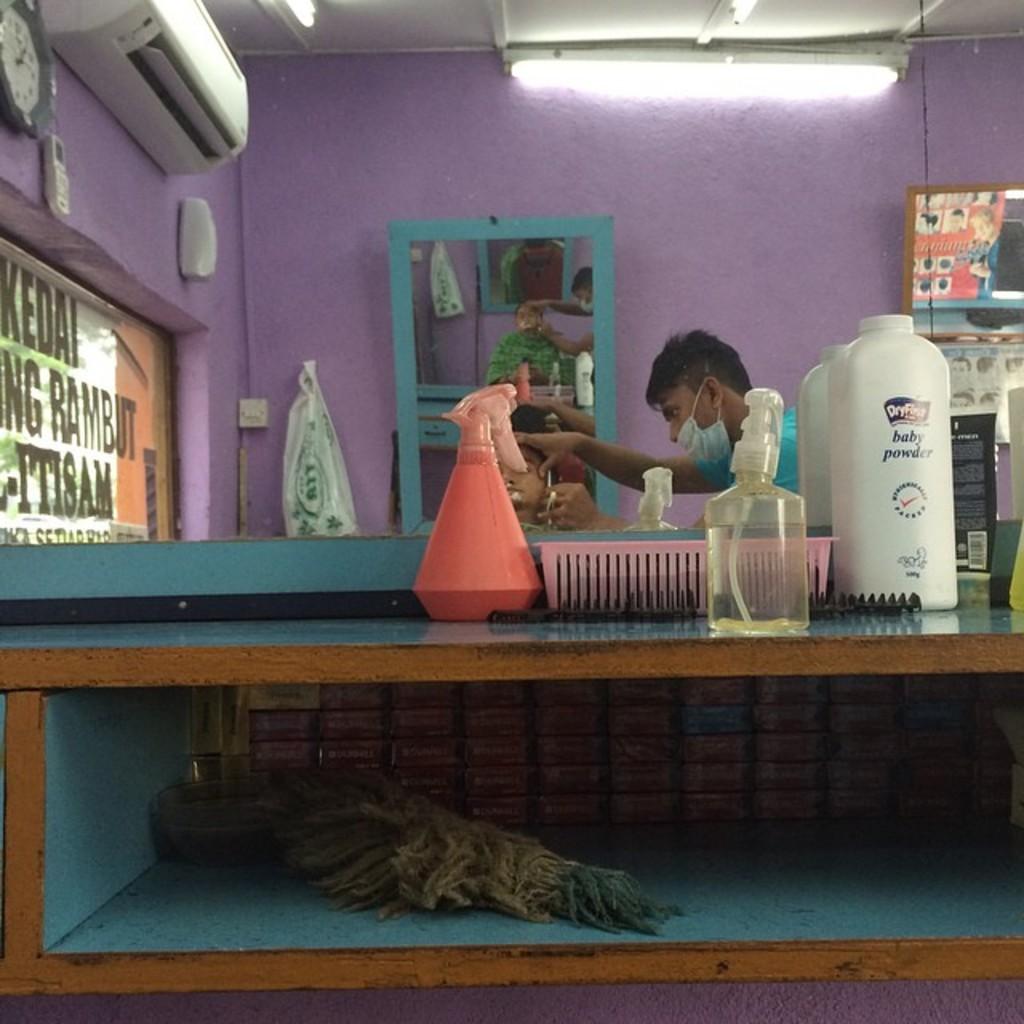Because the baby powder was very import here?
Provide a succinct answer. Yes. 